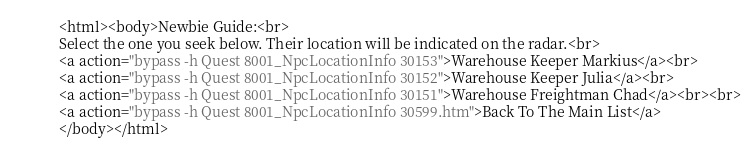<code> <loc_0><loc_0><loc_500><loc_500><_HTML_><html><body>Newbie Guide:<br>
Select the one you seek below. Their location will be indicated on the radar.<br>
<a action="bypass -h Quest 8001_NpcLocationInfo 30153">Warehouse Keeper Markius</a><br>
<a action="bypass -h Quest 8001_NpcLocationInfo 30152">Warehouse Keeper Julia</a><br>
<a action="bypass -h Quest 8001_NpcLocationInfo 30151">Warehouse Freightman Chad</a><br><br>
<a action="bypass -h Quest 8001_NpcLocationInfo 30599.htm">Back To The Main List</a>
</body></html></code> 